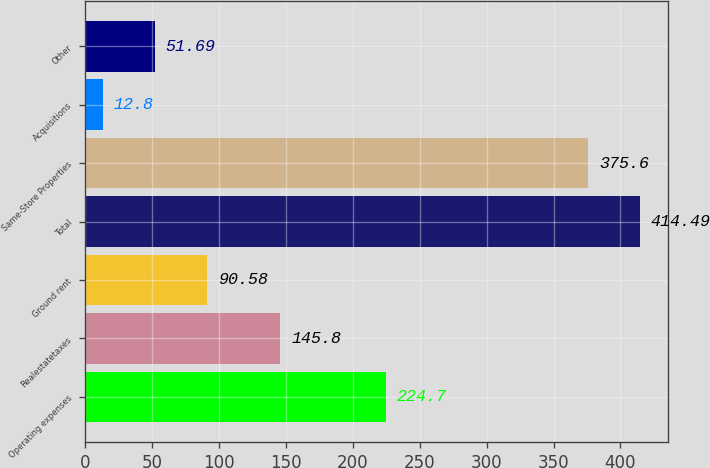Convert chart. <chart><loc_0><loc_0><loc_500><loc_500><bar_chart><fcel>Operating expenses<fcel>Realestatetaxes<fcel>Ground rent<fcel>Total<fcel>Same-Store Properties<fcel>Acquisitions<fcel>Other<nl><fcel>224.7<fcel>145.8<fcel>90.58<fcel>414.49<fcel>375.6<fcel>12.8<fcel>51.69<nl></chart> 